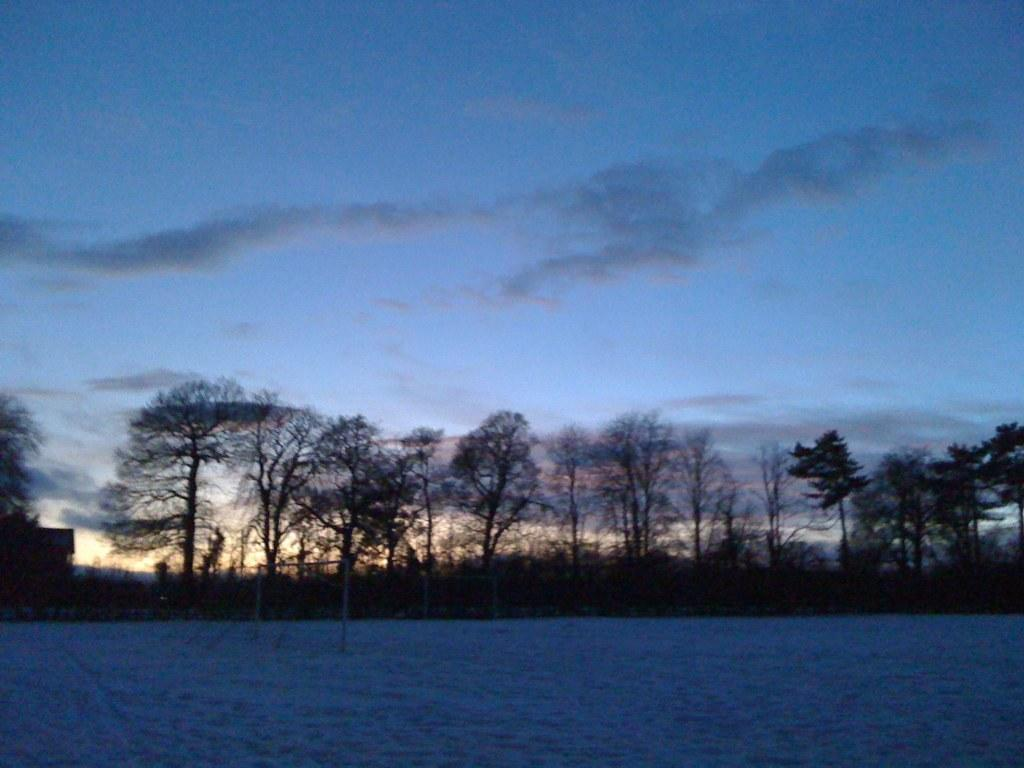What is covering the ground in the image? There is snow on the ground. What is placed on top of the snow? There is a net on the snow. What can be seen in the background of the image? There are trees, plants, and a building in the background. What is the color of the sky in the image? The sky is blue with clouds in the image. What type of paste is being used by the mice in the image? There are no mice or paste present in the image. What kind of music can be heard playing in the background of the image? There is no music present in the image; it only shows snow, a net, trees, plants, a building, and the sky. 